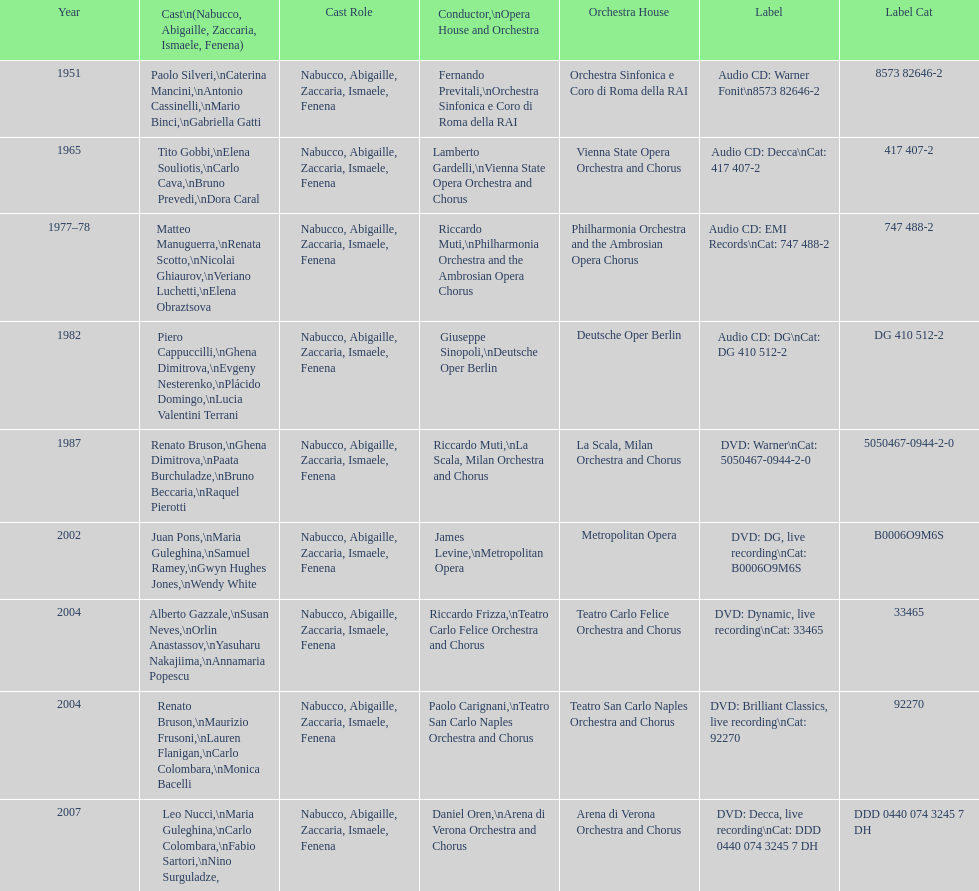How many recordings of nabucco have been made? 9. 